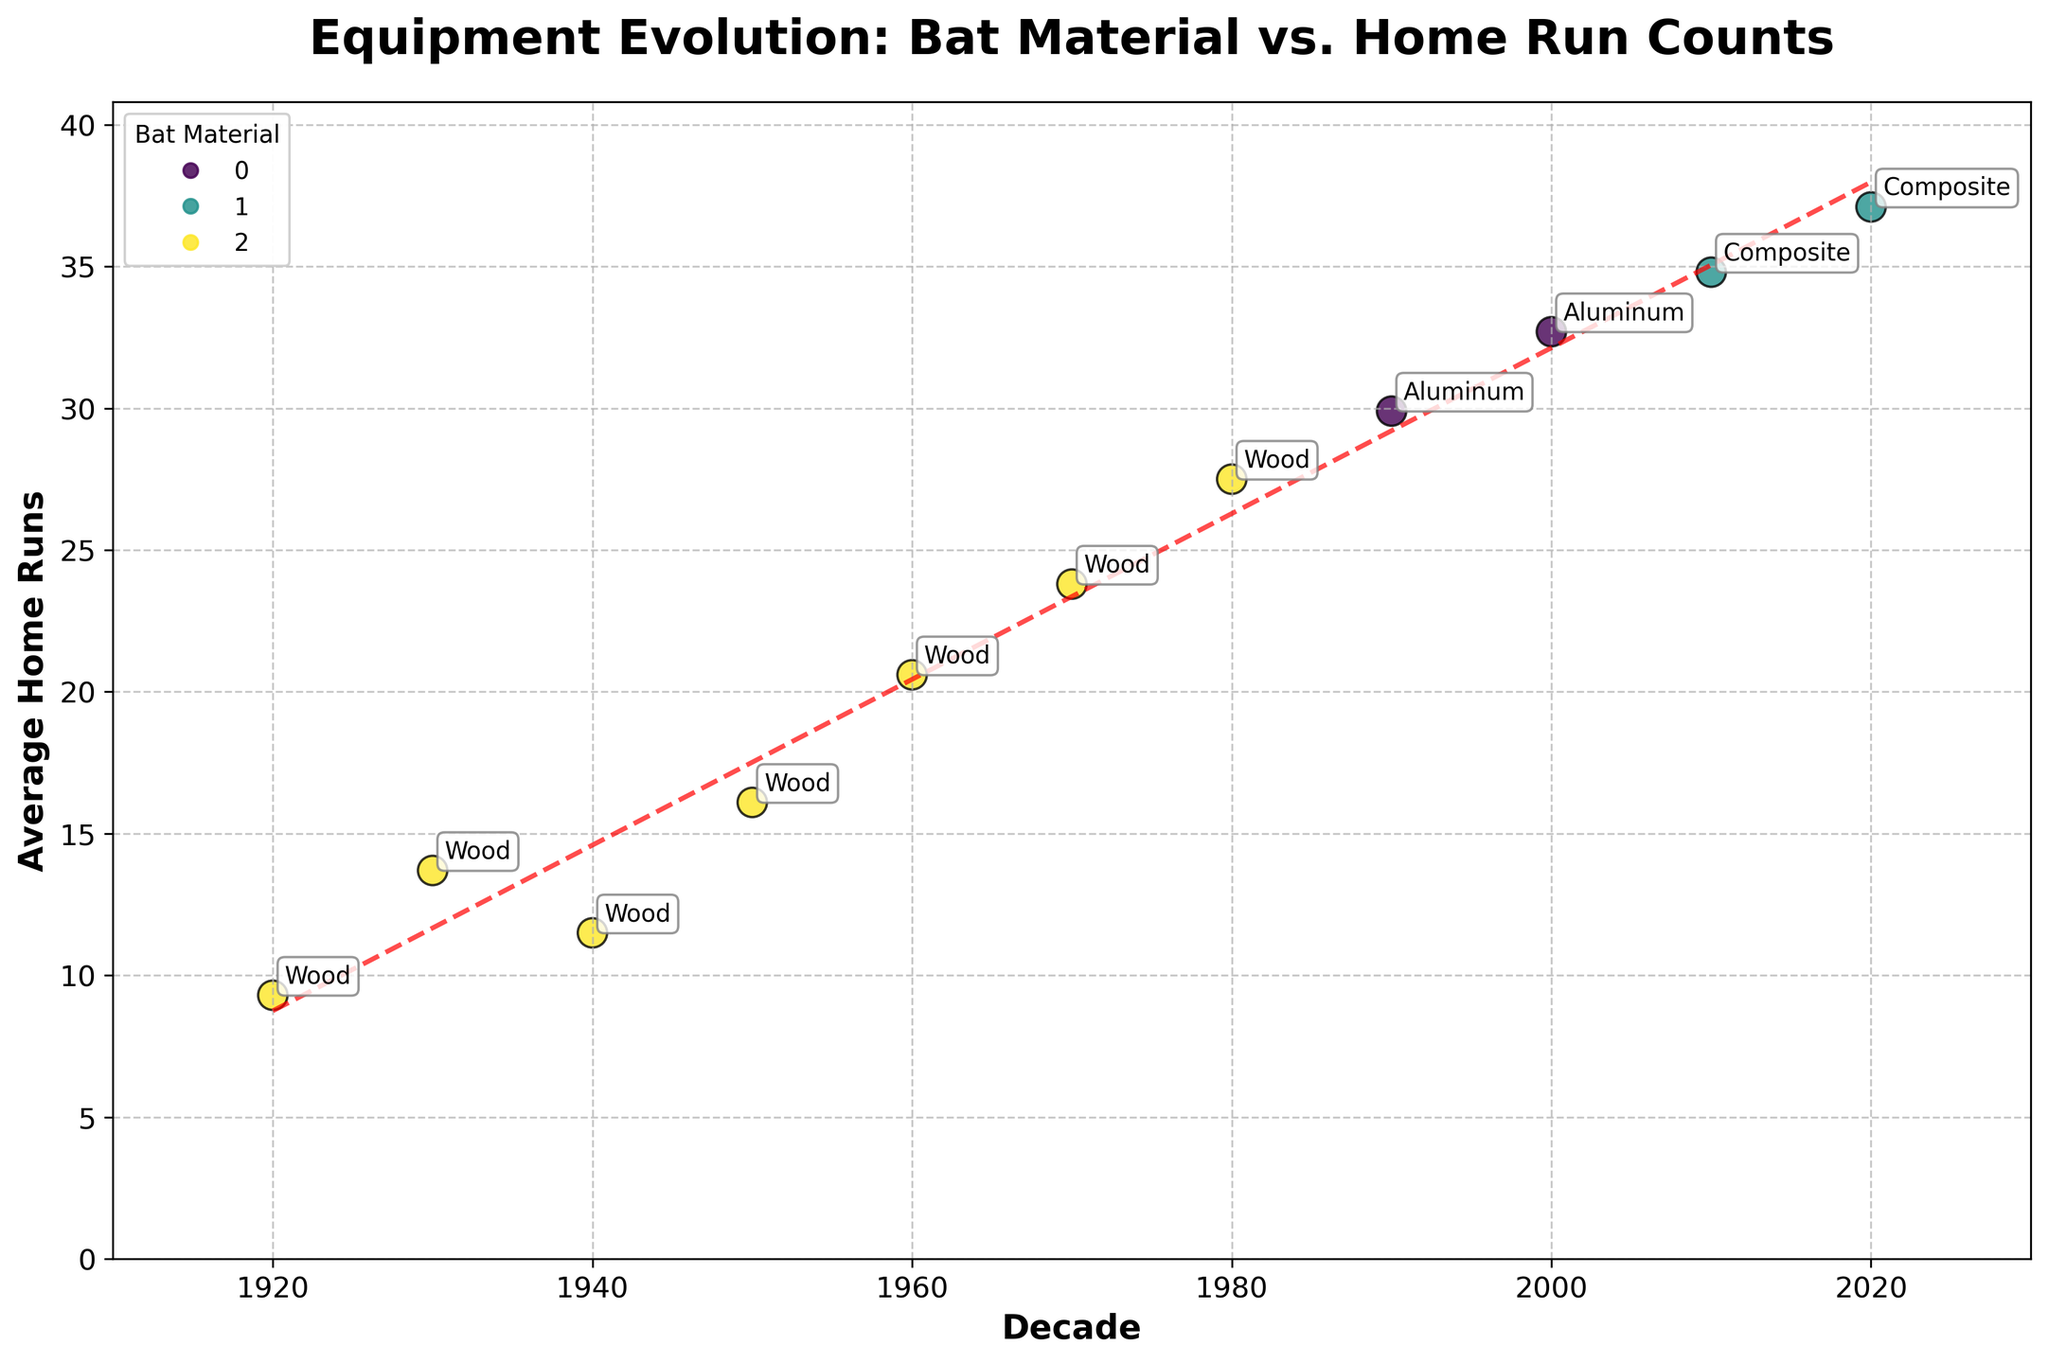Which bat material shows the highest average home run counts? Observing the scatter plot, the data points annotated with "Composite" material show the highest average home run counts in the 2020s (37.1).
Answer: Composite What's the range of average home runs in the data shown? To find the range, subtract the lowest average home runs from the highest. The lowest is 9.3 (1920s, Wood), and the highest is 37.1 (2020s with Composite). So the range is 37.1 - 9.3.
Answer: 27.8 How does the trend line behave over the decades? The trend line, which is dashed red, generally slopes upward from left to right, indicating an overall increase in average home runs over the decades.
Answer: Upward How many different bat materials are represented in the scatter plot? The legend in the upper left part of the scatter plot shows three different bat materials: Wood, Aluminum, and Composite.
Answer: 3 In which decade did bats change from Wood to Aluminum? The transition from Wood to Aluminum occurred in the 1990s, as annotated on the scatter plot.
Answer: 1990s What is the average increase in home runs per decade, as indicated by the trend line? The trend line is a linear approximation with a slope. To estimate this, fit a line to the plot data. The slope (increase per unit) suggests the approximate increase in average home runs per decade. The precise calculation would be available in the code fitting the trend line; as visual estimate, the slope (increase) can be averaged from one end to the other.
Answer: Approximately 3 Which decade had the most significant improvement in average home runs compared to the previous decade? Comparing the vertical distances between consecutive points, the 1960s had the most significant improvement (from 16.1 to 20.6). The difference is 4.5 home runs.
Answer: 1960s How many decades use composite bat material, and what's their average home run count? Look for the points annotated with "Composite". They are for the 2010s and 2020s. The average home runs for these decades are 34.8 and 37.1, respectively. To find the overall average: \((34.8 + 37.1)/2 = 35.95\).
Answer: 2, 35.95 Is there a period where there is no change in the bat material? From the 1920s through the 1980s, all data points are annotated with "Wood", indicating no change in material during these decades.
Answer: 1920s-1980s What visual marker indicates different bat materials in the scatter plot? The different bat materials are indicated by different colors in the scatter plot, as shown in the legend.
Answer: Colors 